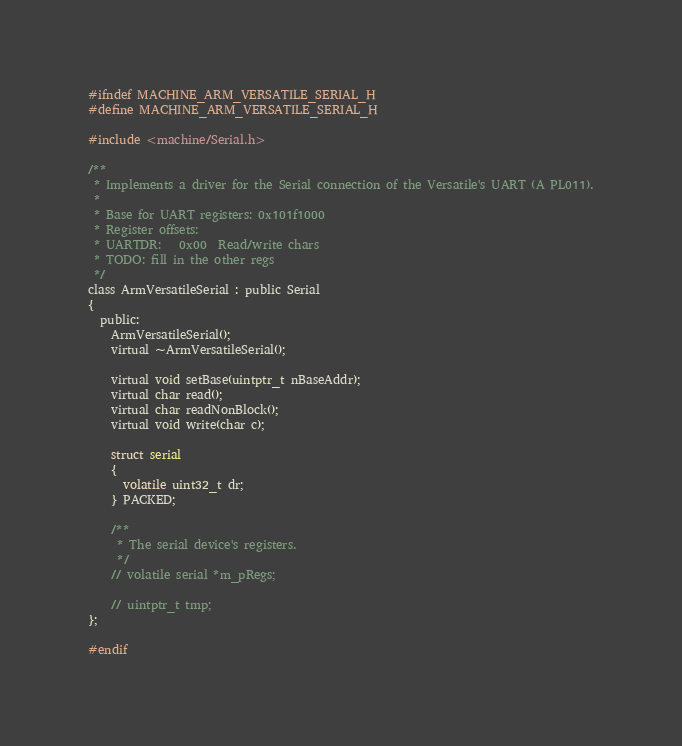Convert code to text. <code><loc_0><loc_0><loc_500><loc_500><_C_>#ifndef MACHINE_ARM_VERSATILE_SERIAL_H
#define MACHINE_ARM_VERSATILE_SERIAL_H

#include <machine/Serial.h>

/**
 * Implements a driver for the Serial connection of the Versatile's UART (A PL011).
 * 
 * Base for UART registers: 0x101f1000
 * Register offsets:
 * UARTDR:   0x00  Read/write chars
 * TODO: fill in the other regs
 */
class ArmVersatileSerial : public Serial
{
  public:
    ArmVersatileSerial();
    virtual ~ArmVersatileSerial();
  
    virtual void setBase(uintptr_t nBaseAddr);
    virtual char read();
    virtual char readNonBlock();
    virtual void write(char c);
    
    struct serial
    {
      volatile uint32_t dr;
    } PACKED;
    
    /**
     * The serial device's registers.
     */
    // volatile serial *m_pRegs;
    
    // uintptr_t tmp;
};

#endif
</code> 